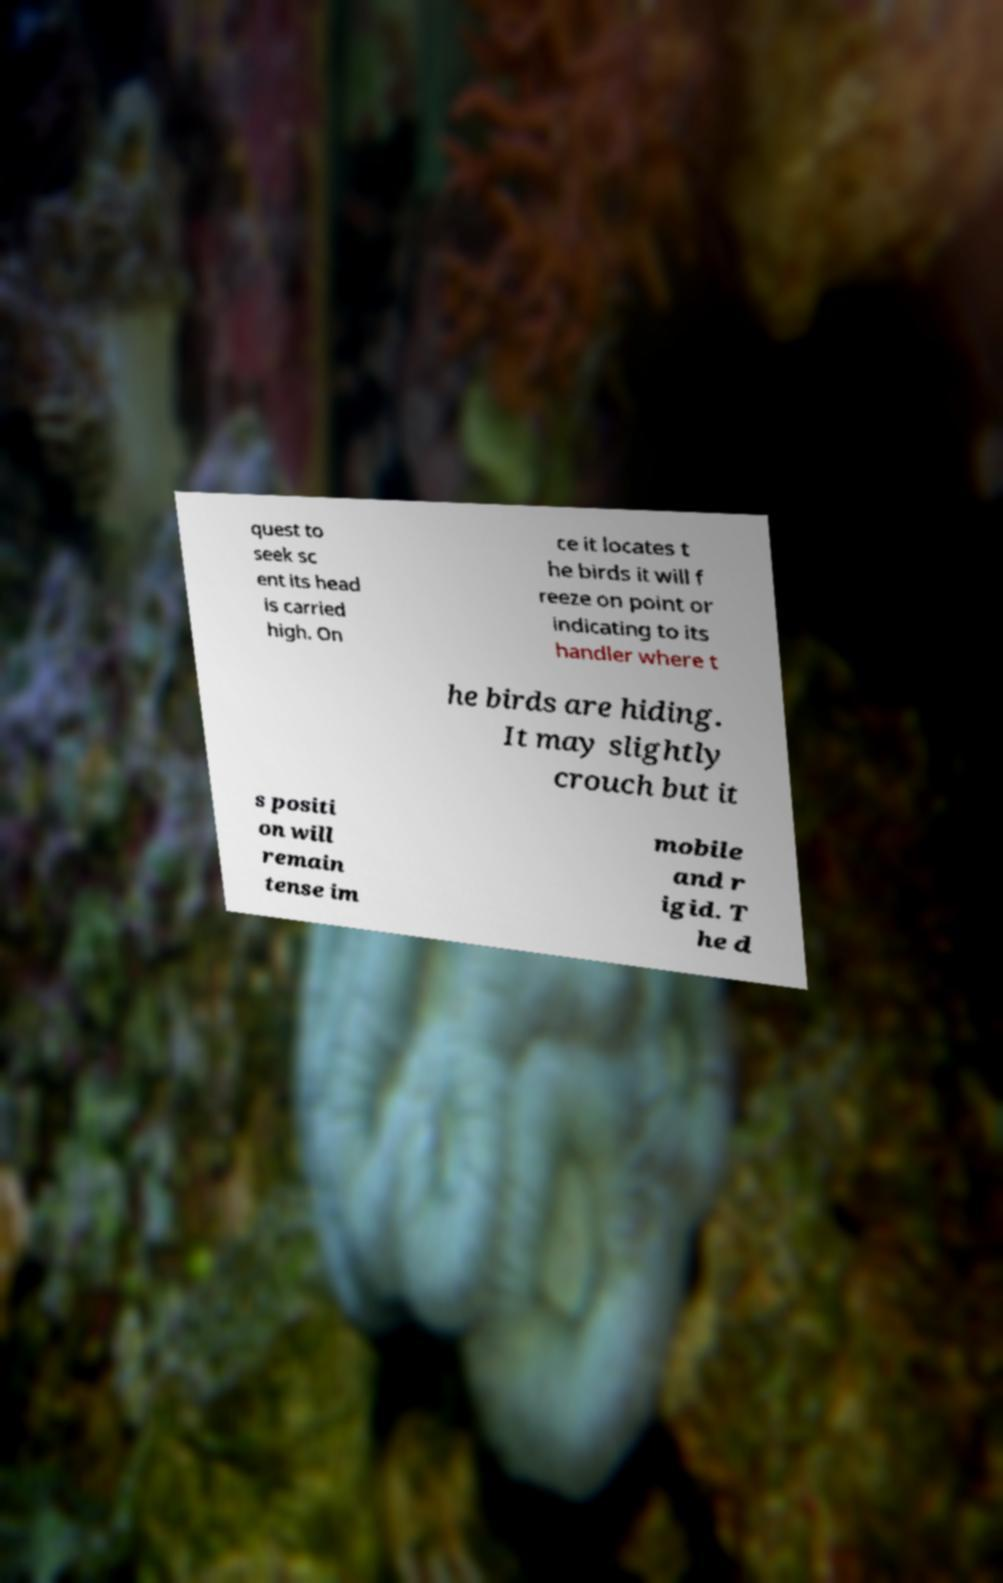Could you extract and type out the text from this image? quest to seek sc ent its head is carried high. On ce it locates t he birds it will f reeze on point or indicating to its handler where t he birds are hiding. It may slightly crouch but it s positi on will remain tense im mobile and r igid. T he d 